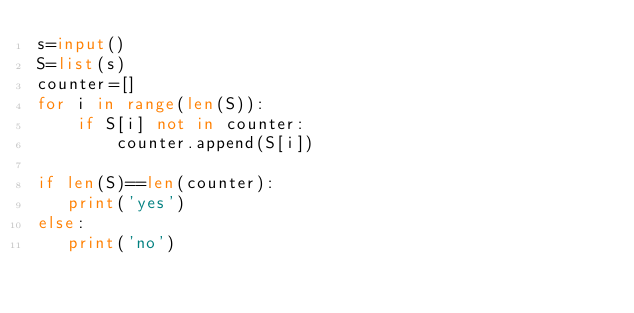Convert code to text. <code><loc_0><loc_0><loc_500><loc_500><_Python_>s=input()
S=list(s)
counter=[]
for i in range(len(S)):
    if S[i] not in counter:
        counter.append(S[i])

if len(S)==len(counter):
   print('yes')
else:
   print('no')</code> 